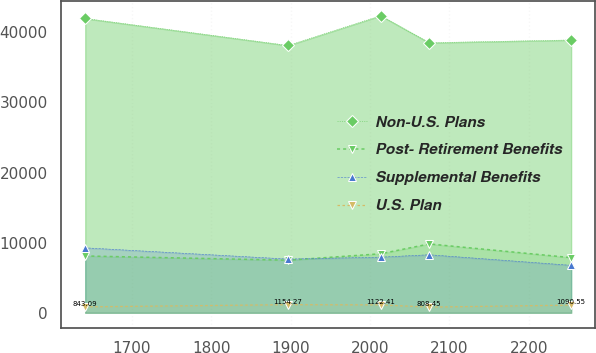<chart> <loc_0><loc_0><loc_500><loc_500><line_chart><ecel><fcel>Non-U.S. Plans<fcel>Post- Retirement Benefits<fcel>Supplemental Benefits<fcel>U.S. Plan<nl><fcel>1641.52<fcel>41987<fcel>8102.01<fcel>9263.61<fcel>843.09<nl><fcel>1896.98<fcel>38132.6<fcel>7497.05<fcel>7659.77<fcel>1154.27<nl><fcel>2013.53<fcel>42380.5<fcel>8415.85<fcel>7931.92<fcel>1122.41<nl><fcel>2074.71<fcel>38526.1<fcel>9819.66<fcel>8276.03<fcel>808.45<nl><fcel>2253.34<fcel>38919.5<fcel>7863.84<fcel>6765.45<fcel>1090.55<nl></chart> 